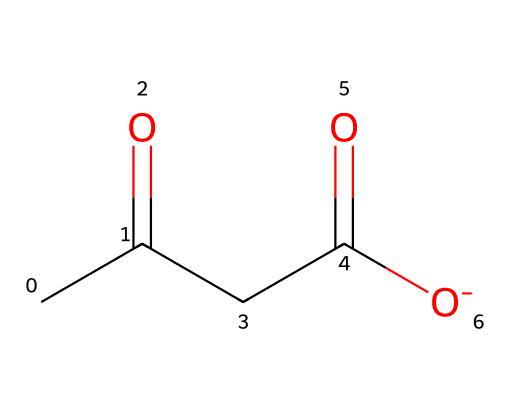What is the molecular formula of acetoacetate? Acetoacetate can be represented by the structure in the SMILES notation, which indicates the presence of two carbonyl groups (C=O) and four carbon atoms in total. Counting the atoms gives the molecular formula C4H7O3.
Answer: C4H7O3 How many carbon atoms are present in acetoacetate? From the SMILES notation, we can see there are four carbon atoms indicated by the "CC(=O)" and "CC(=O)[O-]" segments, which combine to give four carbons in total.
Answer: 4 What type of functional groups does acetoacetate contain? The SMILES notation shows two carbonyl groups (C=O) as part of its structure, which are indicative of the ketone functional group and a carboxylate group (–COO⁻), thus confirming the presence of both functional groups.
Answer: ketone, carboxylate How many double bonds are present in acetoacetate? In the structure, each carbonyl group (C=O) counts as a double bond. Since there are two carbonyls, we can conclude that there are two double bonds in total within the acetoacetate molecule.
Answer: 2 What is the charge of the acetoacetate molecule? The SMILES notation includes "[O-]", indicating that there is a negatively charged oxygen in the molecule, suggesting that acetoacetate is a carboxylate ion, which has a charge of minus one.
Answer: -1 Is acetoacetate a ketone or a carboxylic acid? The presence of the carbonyl group inside the carbon chain indicates that acetoacetate is a ketone, while the carboxylate group points to its acidic property; however, traditionally, it is classified mainly as a ketone due to its structural form.
Answer: ketone 